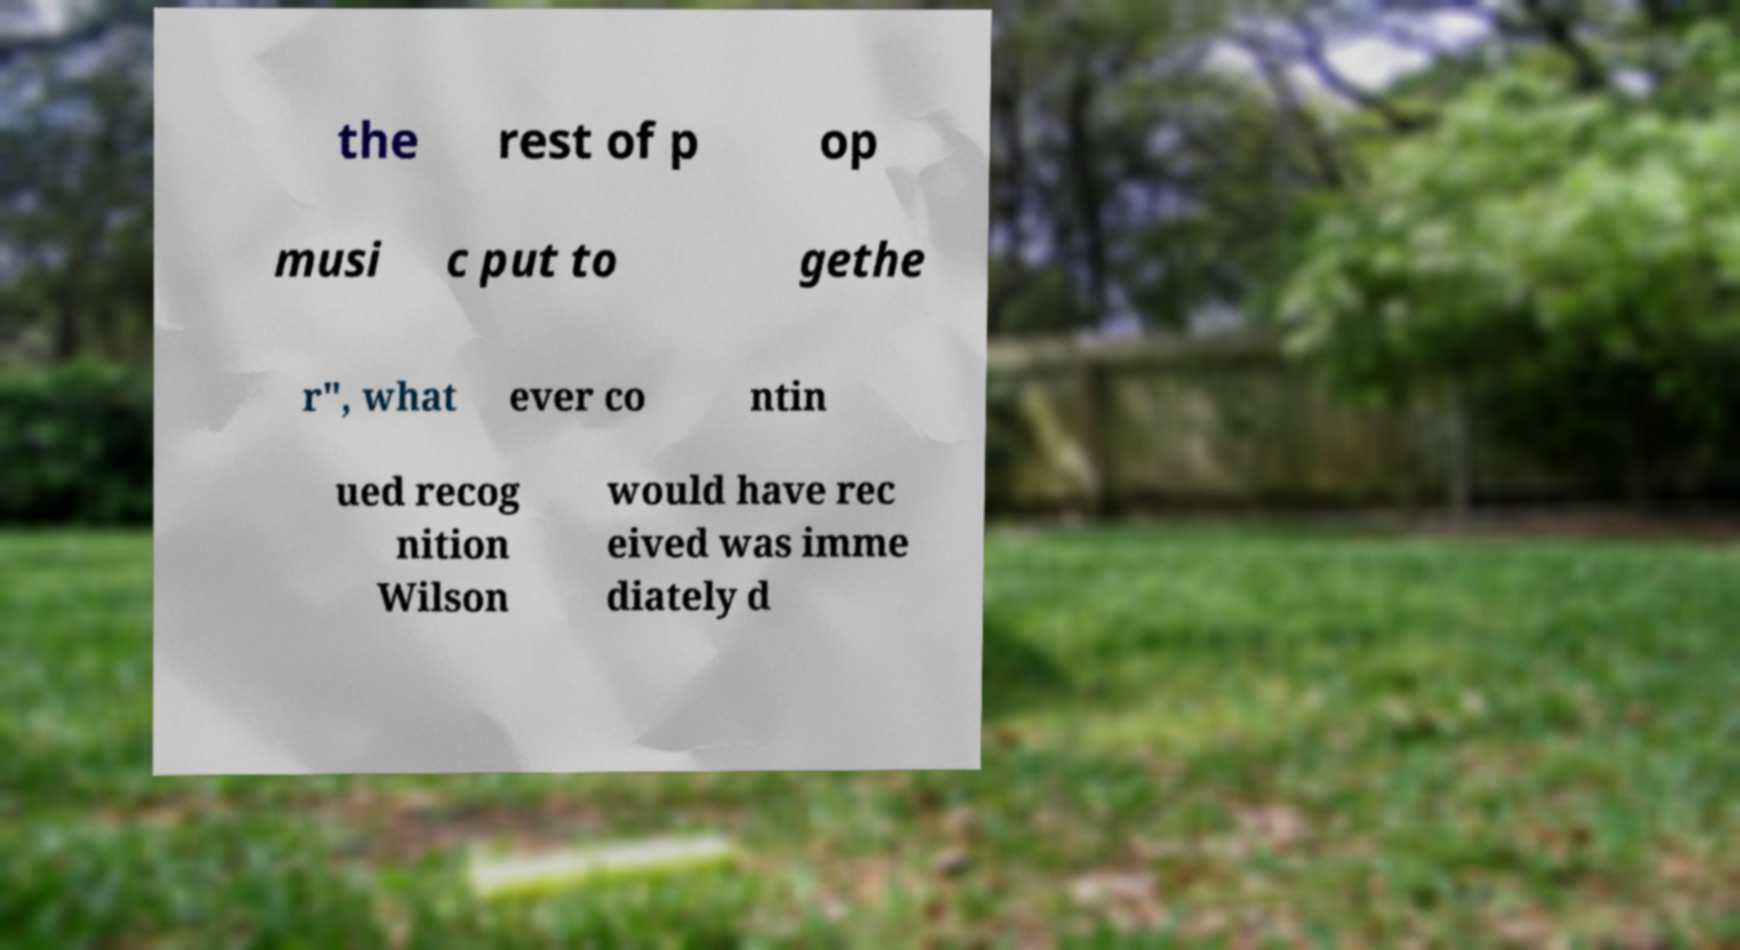I need the written content from this picture converted into text. Can you do that? the rest of p op musi c put to gethe r", what ever co ntin ued recog nition Wilson would have rec eived was imme diately d 